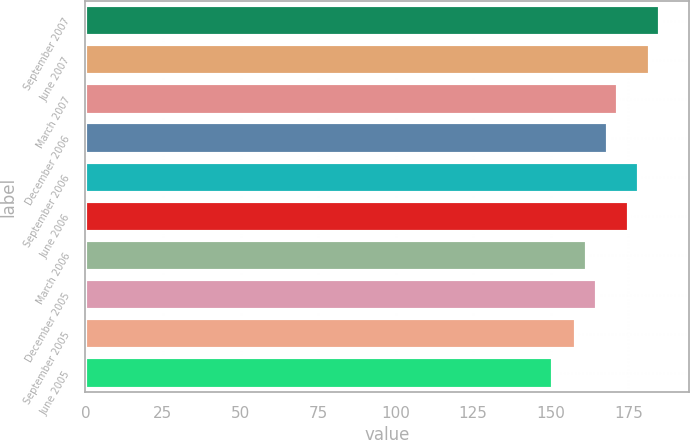Convert chart to OTSL. <chart><loc_0><loc_0><loc_500><loc_500><bar_chart><fcel>September 2007<fcel>June 2007<fcel>March 2007<fcel>December 2006<fcel>September 2006<fcel>June 2006<fcel>March 2006<fcel>December 2005<fcel>September 2005<fcel>June 2005<nl><fcel>185.32<fcel>181.93<fcel>171.76<fcel>168.37<fcel>178.54<fcel>175.15<fcel>161.59<fcel>164.98<fcel>158.2<fcel>150.7<nl></chart> 